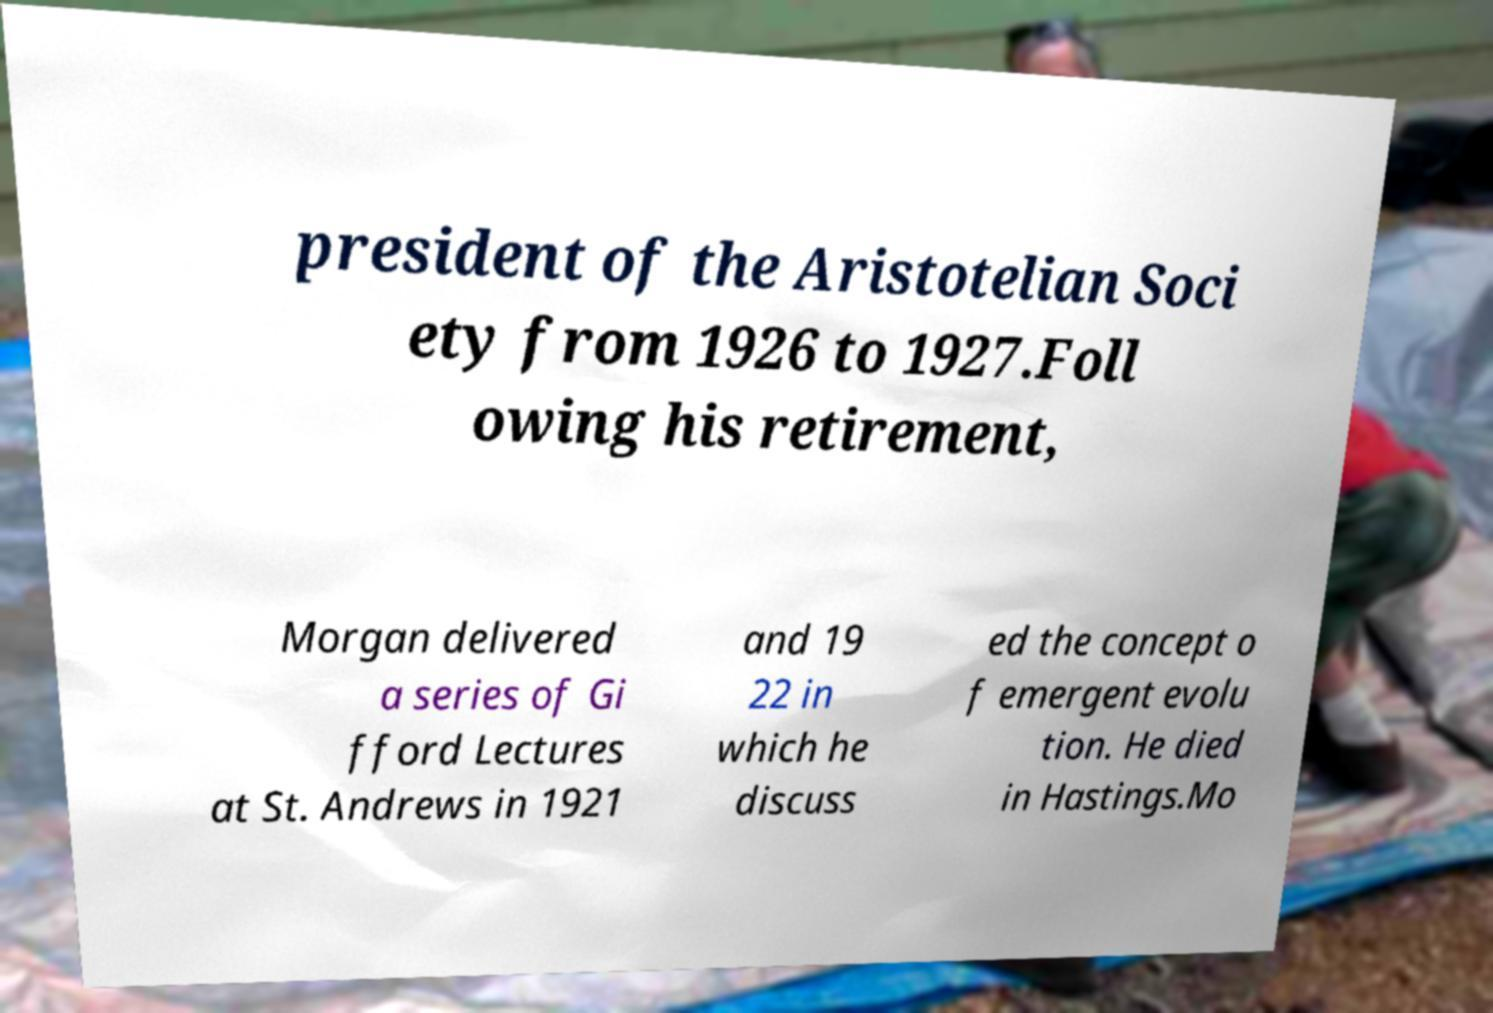Please identify and transcribe the text found in this image. president of the Aristotelian Soci ety from 1926 to 1927.Foll owing his retirement, Morgan delivered a series of Gi fford Lectures at St. Andrews in 1921 and 19 22 in which he discuss ed the concept o f emergent evolu tion. He died in Hastings.Mo 